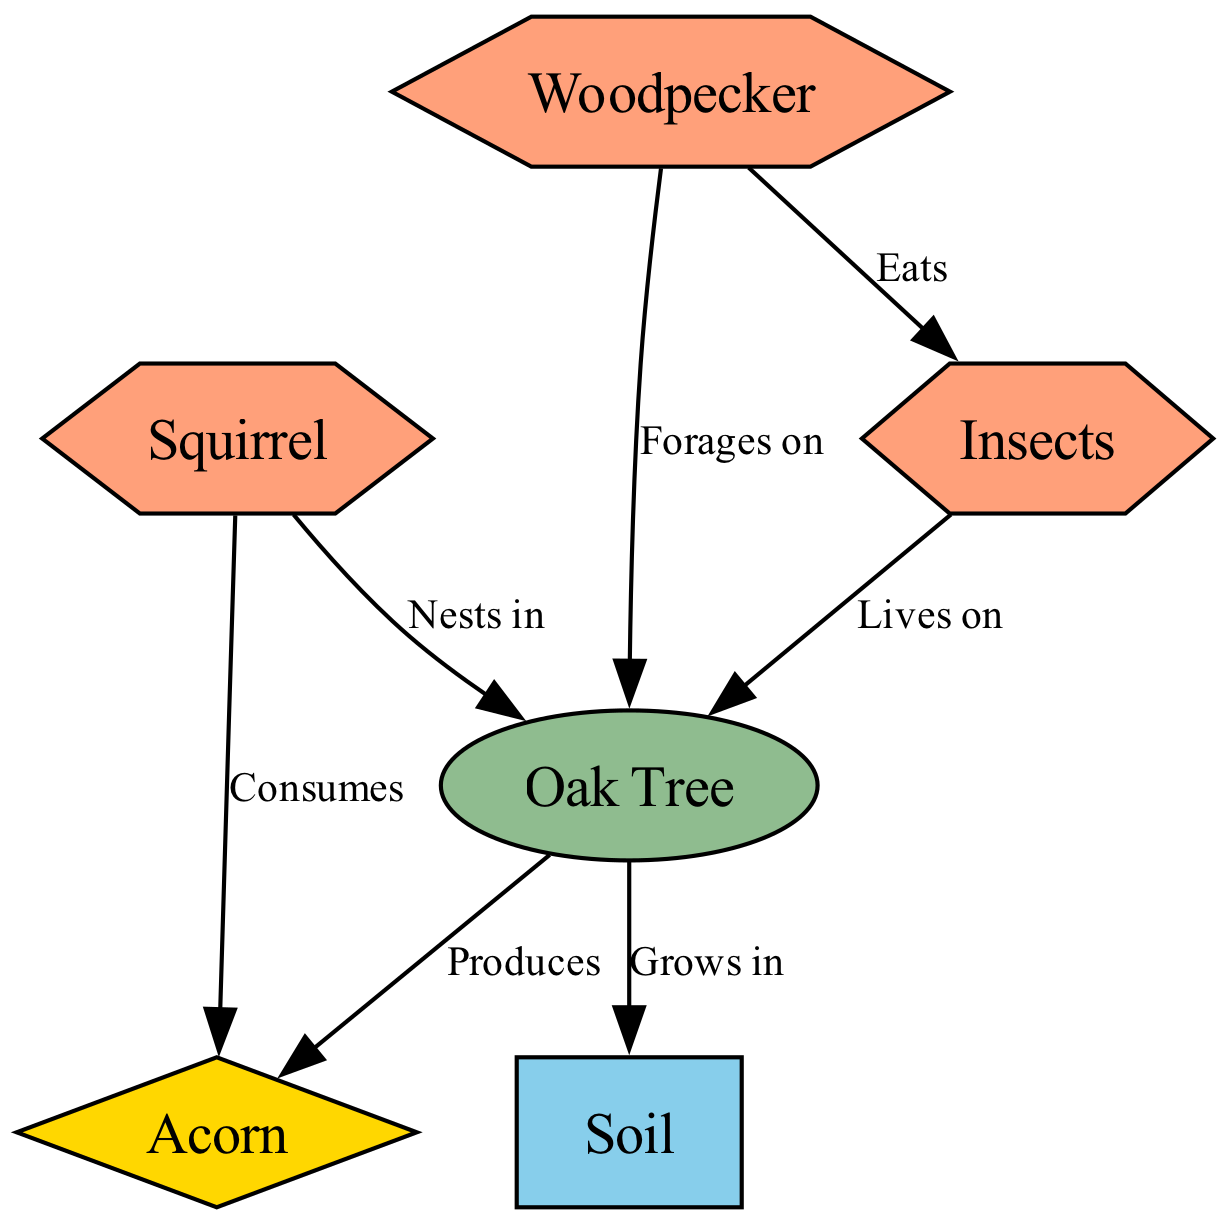What is the total number of nodes in the diagram? The diagram includes six entities: Oak Tree, Squirrel, Acorn, Soil, Woodpecker, and Insects, which are all represented as nodes. Therefore, counting them yields a total of six nodes.
Answer: 6 What type of resource does the Oak Tree produce? According to the diagram, the Oak Tree produces Acorns, which are categorized as a resource. Thus, the specific resource produced is Acorn.
Answer: Acorn Which fauna consumes the Acorn? The diagram clearly indicates that the Squirrel is linked to the Acorn with a "Consumes" relationship. Therefore, the only fauna that consumes Acorns is the Squirrel.
Answer: Squirrel How many connections does the Woodpecker have in the diagram? The Woodpecker has one connection, specifically "Forages on" the Oak Tree. After analyzing the edges, we find that only this single relationship is defined for the Woodpecker.
Answer: 1 What environment does the Oak Tree grow in? The diagram states that the Oak Tree grows in Soil, which is classified as an environment component in the ecosystem. Hence, Soil is the environment where the Oak Tree grows.
Answer: Soil Which fauna species live on the Oak Tree? Based on the diagram, both the Squirrel and the Insects have established connections with the Oak Tree. The Squirrel nests in the Oak Tree, while the Insects live on it. Therefore, both species are found on the Oak Tree.
Answer: Squirrel and Insects Which organism forages on the Oak Tree? The Woodpecker is indicated within the diagram to forage on the Oak Tree, establishing a direct relationship with it. Hence, the organism foraging on the Oak Tree is the Woodpecker.
Answer: Woodpecker What do the Woodpecker and Insects have in common? Both the Woodpecker and Insects are connected to the Oak Tree; however, their relationships differ. The Woodpecker forages on the Oak Tree, while the Insects live on it. Their commonality lies in their ecological association with the Oak Tree.
Answer: They both interact with the Oak Tree 